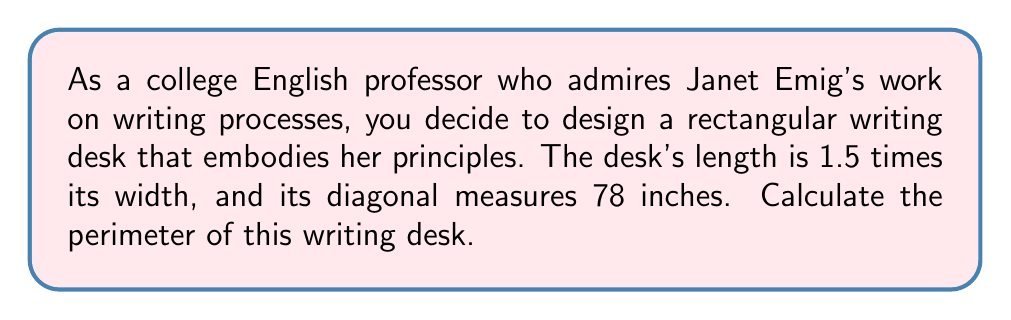Solve this math problem. Let's approach this step-by-step:

1) Let the width of the desk be $w$ and the length be $l$.

2) Given that the length is 1.5 times the width:
   $l = 1.5w$

3) We know that the diagonal of a rectangle forms a right triangle with the length and width. We can use the Pythagorean theorem:
   $w^2 + l^2 = d^2$, where $d$ is the diagonal

4) Substituting the known values:
   $w^2 + (1.5w)^2 = 78^2$

5) Simplify:
   $w^2 + 2.25w^2 = 6084$
   $3.25w^2 = 6084$

6) Solve for $w$:
   $w^2 = 6084 / 3.25 = 1872$
   $w = \sqrt{1872} \approx 43.27$ inches

7) Calculate length:
   $l = 1.5w \approx 64.91$ inches

8) The perimeter of a rectangle is given by $2(l + w)$:
   $\text{Perimeter} = 2(64.91 + 43.27) \approx 216.36$ inches

[asy]
unitsize(1inch);
pair A=(0,0), B=(1.73,0), C=(1.73,1.15), D=(0,1.15);
draw(A--B--C--D--cycle);
label("43.27\"", (A+B)/2, S);
label("64.91\"", (B+C)/2, E);
label("78\"", (A+C)/2, NW);
[/asy]
Answer: $216.36$ inches 